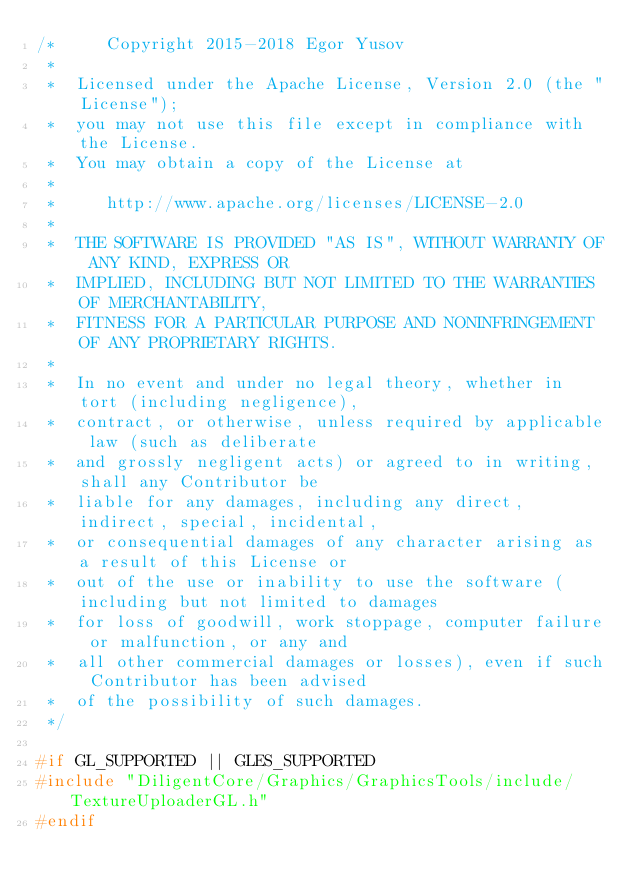Convert code to text. <code><loc_0><loc_0><loc_500><loc_500><_C++_>/*     Copyright 2015-2018 Egor Yusov
 *  
 *  Licensed under the Apache License, Version 2.0 (the "License");
 *  you may not use this file except in compliance with the License.
 *  You may obtain a copy of the License at
 * 
 *     http://www.apache.org/licenses/LICENSE-2.0
 * 
 *  THE SOFTWARE IS PROVIDED "AS IS", WITHOUT WARRANTY OF ANY KIND, EXPRESS OR
 *  IMPLIED, INCLUDING BUT NOT LIMITED TO THE WARRANTIES OF MERCHANTABILITY,
 *  FITNESS FOR A PARTICULAR PURPOSE AND NONINFRINGEMENT OF ANY PROPRIETARY RIGHTS.
 *
 *  In no event and under no legal theory, whether in tort (including negligence), 
 *  contract, or otherwise, unless required by applicable law (such as deliberate 
 *  and grossly negligent acts) or agreed to in writing, shall any Contributor be
 *  liable for any damages, including any direct, indirect, special, incidental, 
 *  or consequential damages of any character arising as a result of this License or 
 *  out of the use or inability to use the software (including but not limited to damages 
 *  for loss of goodwill, work stoppage, computer failure or malfunction, or any and 
 *  all other commercial damages or losses), even if such Contributor has been advised 
 *  of the possibility of such damages.
 */

#if GL_SUPPORTED || GLES_SUPPORTED
#include "DiligentCore/Graphics/GraphicsTools/include/TextureUploaderGL.h"
#endif</code> 